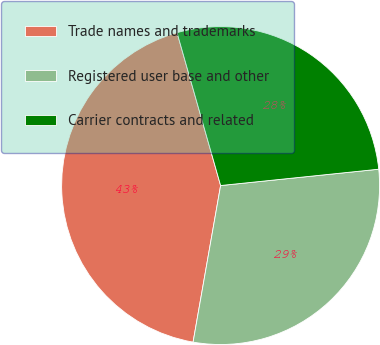<chart> <loc_0><loc_0><loc_500><loc_500><pie_chart><fcel>Trade names and trademarks<fcel>Registered user base and other<fcel>Carrier contracts and related<nl><fcel>42.81%<fcel>29.41%<fcel>27.78%<nl></chart> 